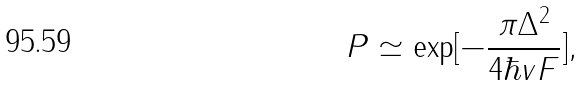<formula> <loc_0><loc_0><loc_500><loc_500>P \simeq \exp [ - \frac { \pi \Delta ^ { 2 } } { 4 \hbar { v } F } ] ,</formula> 